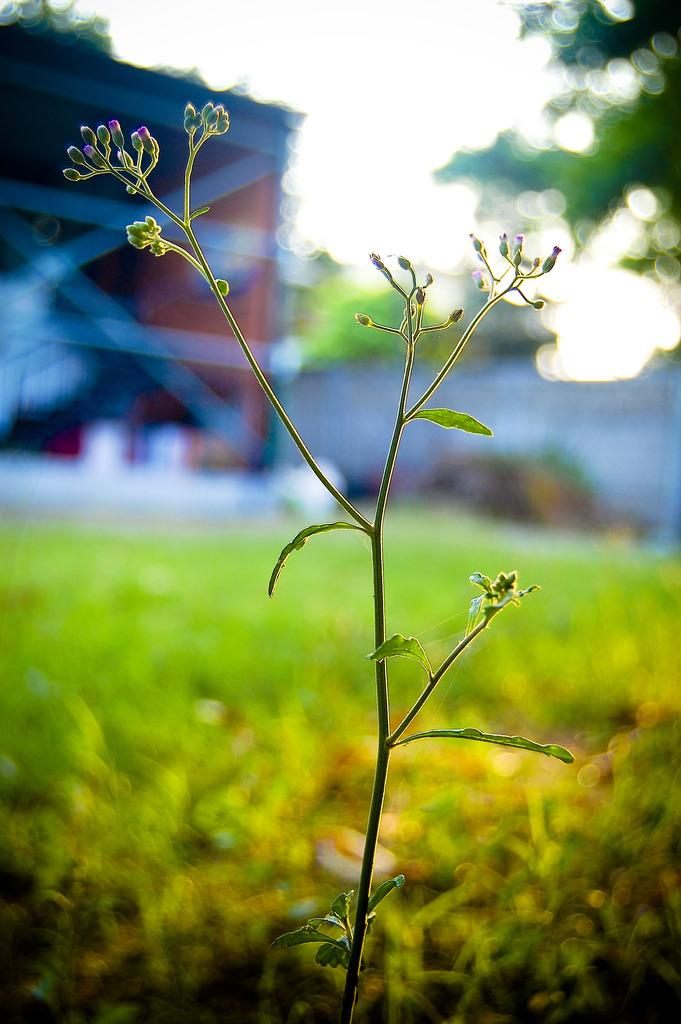What is present in the image? There is a plant in the image. Can you describe the background of the image? The background of the image is blurred. What type of care does the plant require in the image? There is no information provided about the plant's care requirements in the image. How does the plant use its tongue in the image? Plants do not have tongues, so this question cannot be answered based on the information provided. 